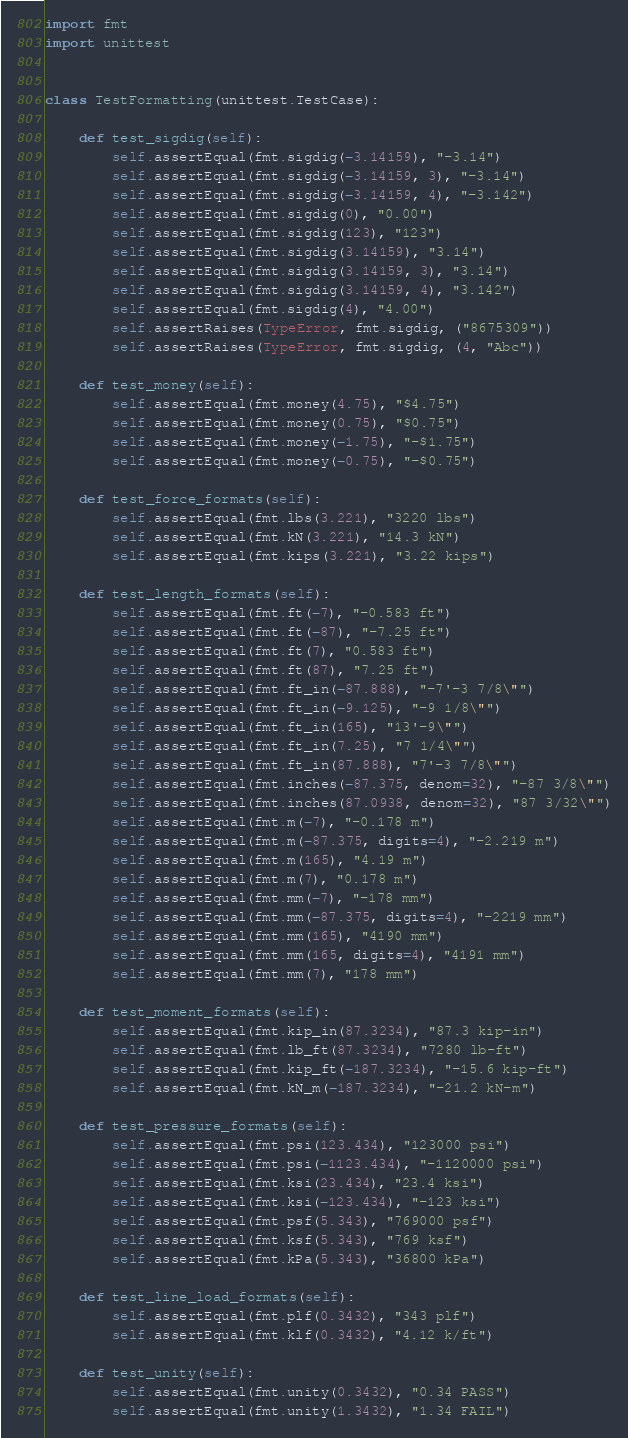<code> <loc_0><loc_0><loc_500><loc_500><_Python_>import fmt
import unittest


class TestFormatting(unittest.TestCase):

    def test_sigdig(self):
        self.assertEqual(fmt.sigdig(-3.14159), "-3.14")
        self.assertEqual(fmt.sigdig(-3.14159, 3), "-3.14")
        self.assertEqual(fmt.sigdig(-3.14159, 4), "-3.142")
        self.assertEqual(fmt.sigdig(0), "0.00")
        self.assertEqual(fmt.sigdig(123), "123")
        self.assertEqual(fmt.sigdig(3.14159), "3.14")
        self.assertEqual(fmt.sigdig(3.14159, 3), "3.14")
        self.assertEqual(fmt.sigdig(3.14159, 4), "3.142")
        self.assertEqual(fmt.sigdig(4), "4.00")
        self.assertRaises(TypeError, fmt.sigdig, ("8675309"))
        self.assertRaises(TypeError, fmt.sigdig, (4, "Abc"))

    def test_money(self):
        self.assertEqual(fmt.money(4.75), "$4.75")
        self.assertEqual(fmt.money(0.75), "$0.75")
        self.assertEqual(fmt.money(-1.75), "-$1.75")
        self.assertEqual(fmt.money(-0.75), "-$0.75")

    def test_force_formats(self):
        self.assertEqual(fmt.lbs(3.221), "3220 lbs")
        self.assertEqual(fmt.kN(3.221), "14.3 kN")
        self.assertEqual(fmt.kips(3.221), "3.22 kips")

    def test_length_formats(self):
        self.assertEqual(fmt.ft(-7), "-0.583 ft")
        self.assertEqual(fmt.ft(-87), "-7.25 ft")
        self.assertEqual(fmt.ft(7), "0.583 ft")
        self.assertEqual(fmt.ft(87), "7.25 ft")
        self.assertEqual(fmt.ft_in(-87.888), "-7'-3 7/8\"")
        self.assertEqual(fmt.ft_in(-9.125), "-9 1/8\"")
        self.assertEqual(fmt.ft_in(165), "13'-9\"")
        self.assertEqual(fmt.ft_in(7.25), "7 1/4\"")
        self.assertEqual(fmt.ft_in(87.888), "7'-3 7/8\"")
        self.assertEqual(fmt.inches(-87.375, denom=32), "-87 3/8\"")
        self.assertEqual(fmt.inches(87.0938, denom=32), "87 3/32\"")
        self.assertEqual(fmt.m(-7), "-0.178 m")
        self.assertEqual(fmt.m(-87.375, digits=4), "-2.219 m")
        self.assertEqual(fmt.m(165), "4.19 m")
        self.assertEqual(fmt.m(7), "0.178 m")
        self.assertEqual(fmt.mm(-7), "-178 mm")
        self.assertEqual(fmt.mm(-87.375, digits=4), "-2219 mm")
        self.assertEqual(fmt.mm(165), "4190 mm")
        self.assertEqual(fmt.mm(165, digits=4), "4191 mm")
        self.assertEqual(fmt.mm(7), "178 mm")

    def test_moment_formats(self):
        self.assertEqual(fmt.kip_in(87.3234), "87.3 kip-in")
        self.assertEqual(fmt.lb_ft(87.3234), "7280 lb-ft")
        self.assertEqual(fmt.kip_ft(-187.3234), "-15.6 kip-ft")
        self.assertEqual(fmt.kN_m(-187.3234), "-21.2 kN-m")

    def test_pressure_formats(self):
        self.assertEqual(fmt.psi(123.434), "123000 psi")
        self.assertEqual(fmt.psi(-1123.434), "-1120000 psi")
        self.assertEqual(fmt.ksi(23.434), "23.4 ksi")
        self.assertEqual(fmt.ksi(-123.434), "-123 ksi")
        self.assertEqual(fmt.psf(5.343), "769000 psf")
        self.assertEqual(fmt.ksf(5.343), "769 ksf")
        self.assertEqual(fmt.kPa(5.343), "36800 kPa")

    def test_line_load_formats(self):
        self.assertEqual(fmt.plf(0.3432), "343 plf")
        self.assertEqual(fmt.klf(0.3432), "4.12 k/ft")

    def test_unity(self):
        self.assertEqual(fmt.unity(0.3432), "0.34 PASS")
        self.assertEqual(fmt.unity(1.3432), "1.34 FAIL")</code> 